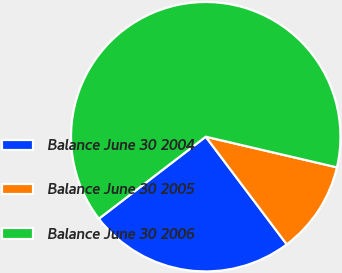<chart> <loc_0><loc_0><loc_500><loc_500><pie_chart><fcel>Balance June 30 2004<fcel>Balance June 30 2005<fcel>Balance June 30 2006<nl><fcel>24.85%<fcel>11.08%<fcel>64.07%<nl></chart> 